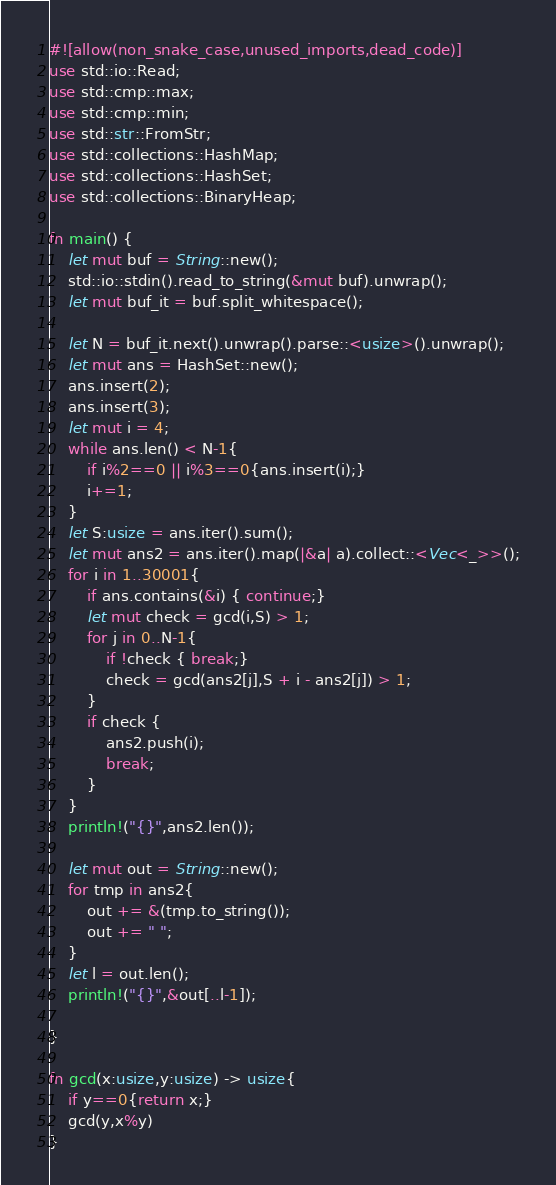<code> <loc_0><loc_0><loc_500><loc_500><_Rust_>#![allow(non_snake_case,unused_imports,dead_code)]
use std::io::Read;
use std::cmp::max;
use std::cmp::min;
use std::str::FromStr;
use std::collections::HashMap;
use std::collections::HashSet;
use std::collections::BinaryHeap;

fn main() {
    let mut buf = String::new();
    std::io::stdin().read_to_string(&mut buf).unwrap();
    let mut buf_it = buf.split_whitespace();

    let N = buf_it.next().unwrap().parse::<usize>().unwrap();
    let mut ans = HashSet::new();
    ans.insert(2);
    ans.insert(3);
    let mut i = 4;
    while ans.len() < N-1{
        if i%2==0 || i%3==0{ans.insert(i);}
        i+=1;
    }
    let S:usize = ans.iter().sum();
    let mut ans2 = ans.iter().map(|&a| a).collect::<Vec<_>>();
    for i in 1..30001{
        if ans.contains(&i) { continue;}
        let mut check = gcd(i,S) > 1;
        for j in 0..N-1{
            if !check { break;}
            check = gcd(ans2[j],S + i - ans2[j]) > 1;
        }
        if check {
            ans2.push(i);
            break;
        }
    }
    println!("{}",ans2.len());
    
    let mut out = String::new();
    for tmp in ans2{
        out += &(tmp.to_string());
        out += " ";
    }
    let l = out.len();
    println!("{}",&out[..l-1]);
    
}

fn gcd(x:usize,y:usize) -> usize{
    if y==0{return x;}
    gcd(y,x%y)
}</code> 